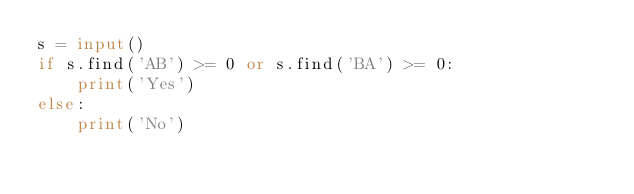Convert code to text. <code><loc_0><loc_0><loc_500><loc_500><_Python_>s = input()
if s.find('AB') >= 0 or s.find('BA') >= 0:
    print('Yes')
else:
    print('No')</code> 